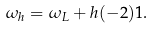Convert formula to latex. <formula><loc_0><loc_0><loc_500><loc_500>\omega _ { h } = \omega _ { L } + h ( - 2 ) 1 .</formula> 